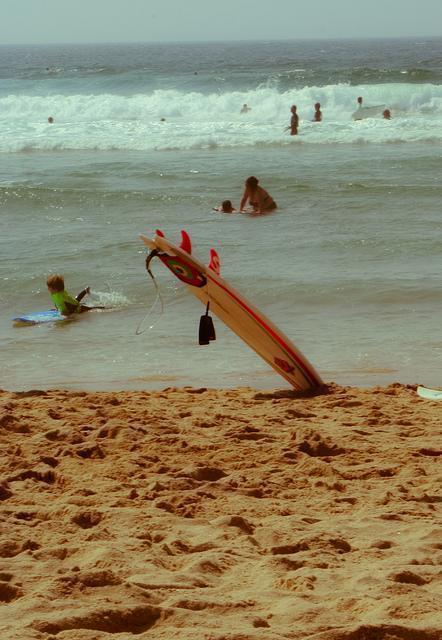What is in the sand?
Indicate the correct choice and explain in the format: 'Answer: answer
Rationale: rationale.'
Options: Baby, cat, old man, surfboard. Answer: surfboard.
Rationale: The item sticking out of the sand vertically has the shape and lower fins and leg attaching cord of a surfboard. 